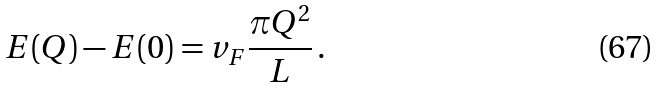<formula> <loc_0><loc_0><loc_500><loc_500>E ( Q ) - E ( 0 ) = v _ { F } \frac { \pi Q ^ { 2 } } { L } \, .</formula> 